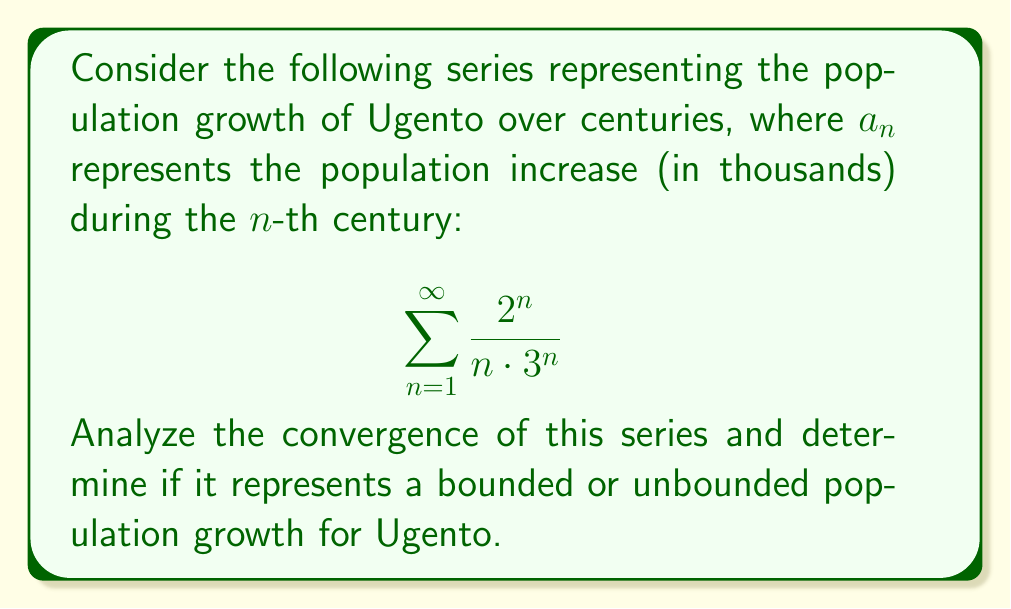Teach me how to tackle this problem. To analyze the convergence of this series, we can use the ratio test:

1) Let $a_n = \frac{2^n}{n \cdot 3^n}$

2) Calculate the limit of the ratio of consecutive terms:
   $$\lim_{n \to \infty} \left|\frac{a_{n+1}}{a_n}\right| = \lim_{n \to \infty} \left|\frac{\frac{2^{n+1}}{(n+1) \cdot 3^{n+1}}}{\frac{2^n}{n \cdot 3^n}}\right|$$

3) Simplify:
   $$\lim_{n \to \infty} \left|\frac{2^{n+1}}{(n+1) \cdot 3^{n+1}} \cdot \frac{n \cdot 3^n}{2^n}\right| = \lim_{n \to \infty} \left|\frac{2n}{3(n+1)}\right|$$

4) Evaluate the limit:
   $$\lim_{n \to \infty} \frac{2n}{3(n+1)} = \lim_{n \to \infty} \frac{2}{3} \cdot \frac{n}{n+1} = \frac{2}{3} < 1$$

5) Since the limit is less than 1, by the ratio test, the series converges.

To interpret this result in the context of Ugento's population growth:

The convergence of the series implies that the total population increase over all centuries is finite. This means the population growth represented by this model is bounded. The population may grow significantly in the early centuries (as the terms $\frac{2^n}{n \cdot 3^n}$ are larger for small $n$), but the growth slows down in later centuries, never reaching an infinite population.

This aligns with realistic population models, where growth tends to slow down or stabilize over very long periods due to factors like resource limitations or changes in social dynamics.
Answer: The series $\sum_{n=1}^{\infty} \frac{2^n}{n \cdot 3^n}$ converges. This represents a bounded population growth for Ugento, where the total population increase over all centuries is finite. 